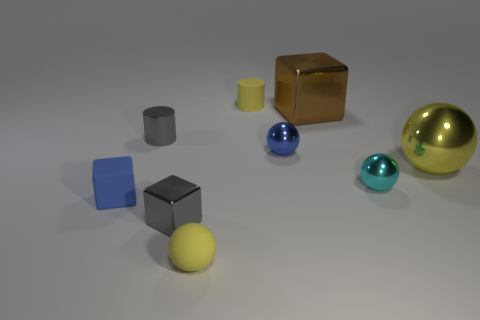Is there a tiny shiny cube of the same color as the tiny metal cylinder?
Your answer should be compact. Yes. Are there any other things that are the same size as the gray block?
Your response must be concise. Yes. What is the color of the small cube that is made of the same material as the large brown thing?
Ensure brevity in your answer.  Gray. There is a tiny rubber thing behind the matte block; is it the same color as the ball that is on the left side of the yellow rubber cylinder?
Ensure brevity in your answer.  Yes. What number of blocks are big things or brown shiny objects?
Ensure brevity in your answer.  1. Are there an equal number of metal blocks to the left of the blue metallic object and blue rubber objects?
Offer a terse response. Yes. What material is the yellow thing that is to the right of the cylinder that is right of the small gray thing behind the blue matte cube?
Your answer should be compact. Metal. There is a big ball that is the same color as the matte cylinder; what is its material?
Your answer should be very brief. Metal. What number of objects are yellow matte objects that are in front of the tiny matte cylinder or gray blocks?
Your response must be concise. 2. What number of things are either tiny green matte spheres or gray objects behind the large yellow metallic ball?
Ensure brevity in your answer.  1. 